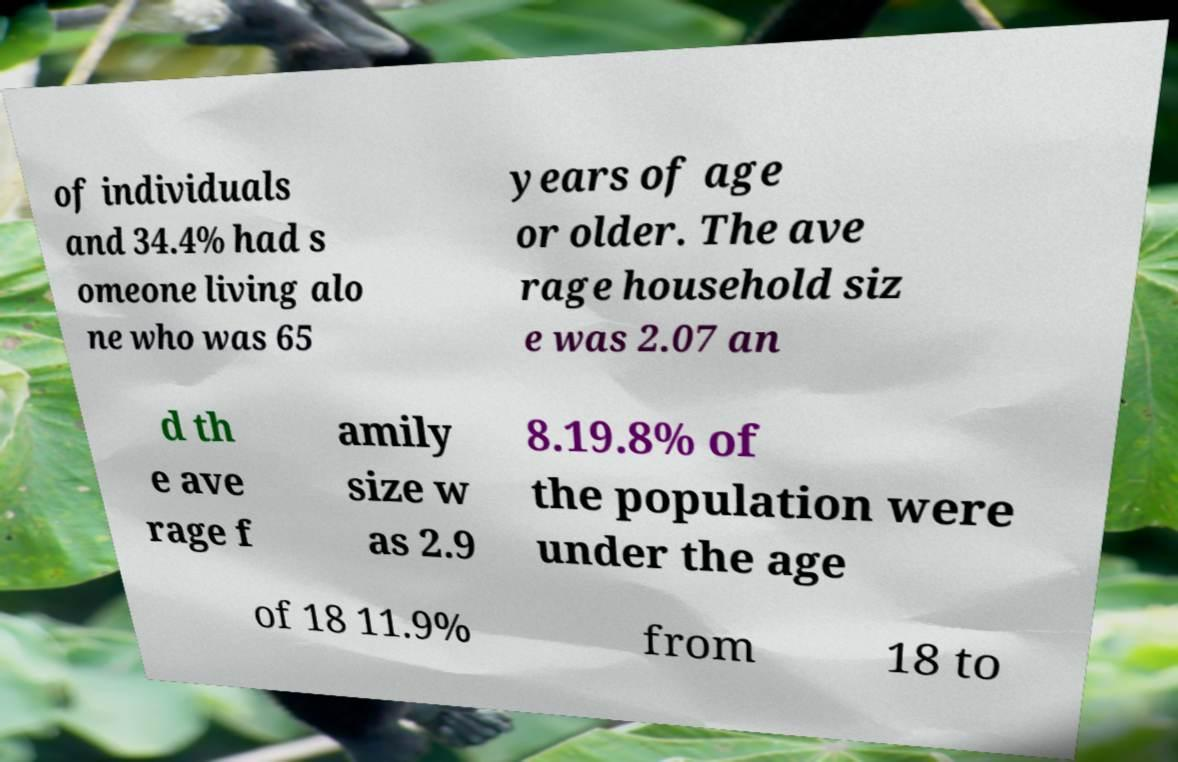Can you read and provide the text displayed in the image?This photo seems to have some interesting text. Can you extract and type it out for me? of individuals and 34.4% had s omeone living alo ne who was 65 years of age or older. The ave rage household siz e was 2.07 an d th e ave rage f amily size w as 2.9 8.19.8% of the population were under the age of 18 11.9% from 18 to 